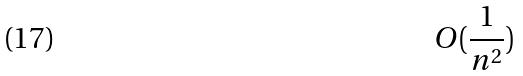<formula> <loc_0><loc_0><loc_500><loc_500>O ( \frac { 1 } { n ^ { 2 } } )</formula> 